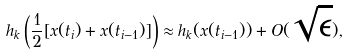Convert formula to latex. <formula><loc_0><loc_0><loc_500><loc_500>h _ { k } \left ( \frac { 1 } { 2 } [ x ( t _ { i } ) + x ( t _ { i - 1 } ) ] \right ) \approx h _ { k } ( x ( t _ { i - 1 } ) ) + O ( \sqrt { \epsilon } ) ,</formula> 